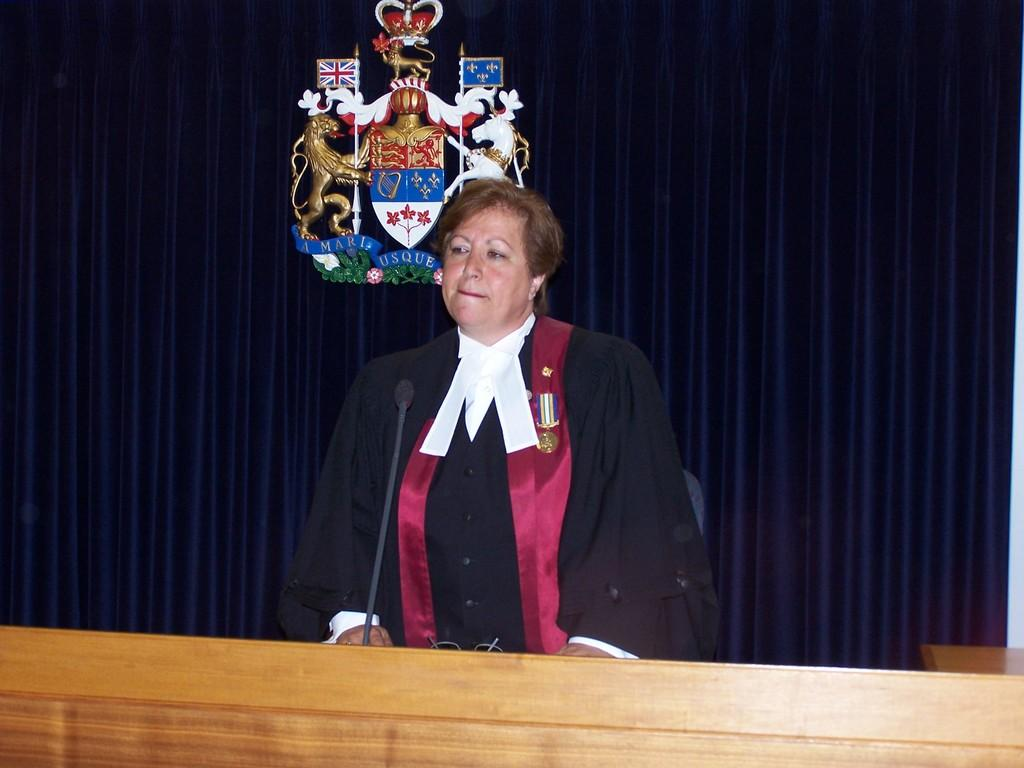What is the person in the image doing? The person is standing in the image. What object is in front of the person? A microphone is present in front of the person. What is on the table in front of the person? There is a spectacle on the table. What can be seen in the background of the image? The background of the image includes a curtain, animal statues, and flags. What type of tank is visible in the image? There is no tank present in the image. What action is the person's daughter performing in the image? There is no daughter present in the image, and therefore no action can be attributed to her. 